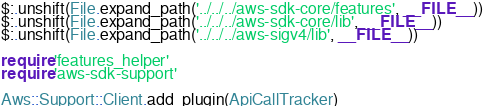<code> <loc_0><loc_0><loc_500><loc_500><_Ruby_>$:.unshift(File.expand_path('../../../aws-sdk-core/features', __FILE__))
$:.unshift(File.expand_path('../../../aws-sdk-core/lib', __FILE__))
$:.unshift(File.expand_path('../../../aws-sigv4/lib', __FILE__))

require 'features_helper'
require 'aws-sdk-support'

Aws::Support::Client.add_plugin(ApiCallTracker)
</code> 